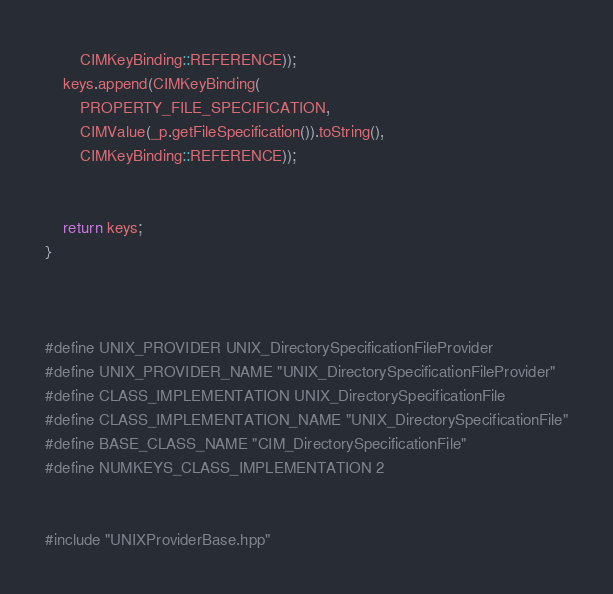<code> <loc_0><loc_0><loc_500><loc_500><_C++_>		CIMKeyBinding::REFERENCE));
	keys.append(CIMKeyBinding(
		PROPERTY_FILE_SPECIFICATION,
		CIMValue(_p.getFileSpecification()).toString(),
		CIMKeyBinding::REFERENCE));


	return keys;
}



#define UNIX_PROVIDER UNIX_DirectorySpecificationFileProvider
#define UNIX_PROVIDER_NAME "UNIX_DirectorySpecificationFileProvider"
#define CLASS_IMPLEMENTATION UNIX_DirectorySpecificationFile
#define CLASS_IMPLEMENTATION_NAME "UNIX_DirectorySpecificationFile"
#define BASE_CLASS_NAME "CIM_DirectorySpecificationFile"
#define NUMKEYS_CLASS_IMPLEMENTATION 2


#include "UNIXProviderBase.hpp"

</code> 